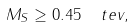<formula> <loc_0><loc_0><loc_500><loc_500>M _ { S } \geq 0 . 4 5 \ \ t e v ,</formula> 